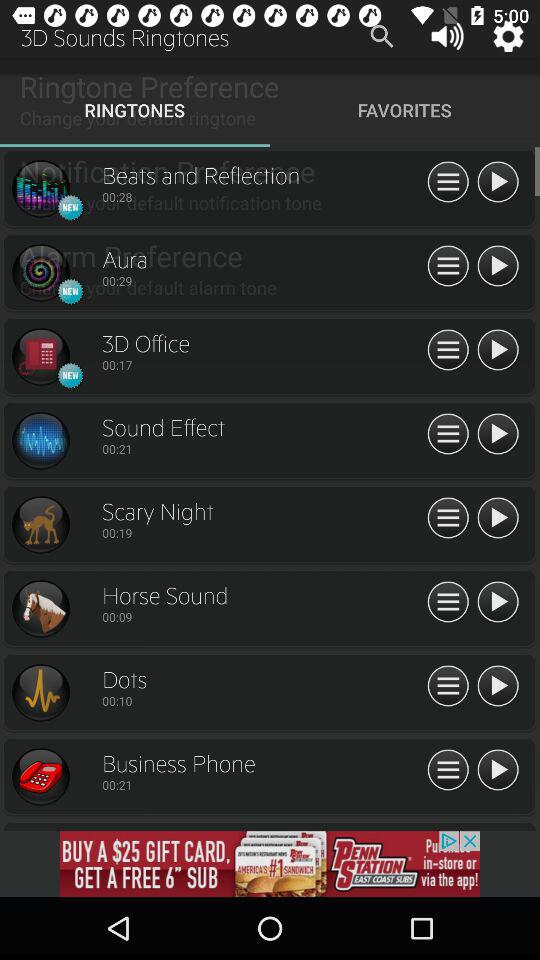What is the duration of the "Horse Sound"? The duration is 9 seconds. 